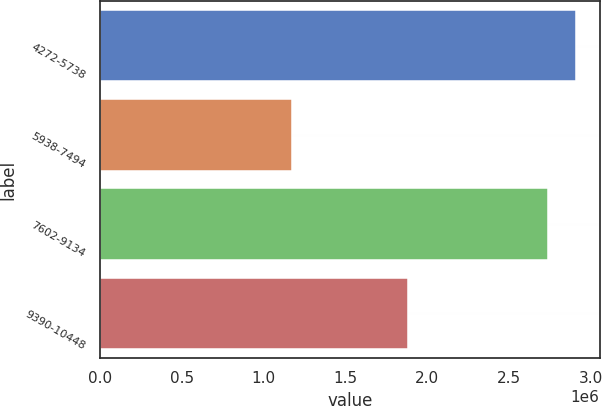Convert chart to OTSL. <chart><loc_0><loc_0><loc_500><loc_500><bar_chart><fcel>4272-5738<fcel>5938-7494<fcel>7602-9134<fcel>9390-10448<nl><fcel>2.90737e+06<fcel>1.17208e+06<fcel>2.73485e+06<fcel>1.88073e+06<nl></chart> 